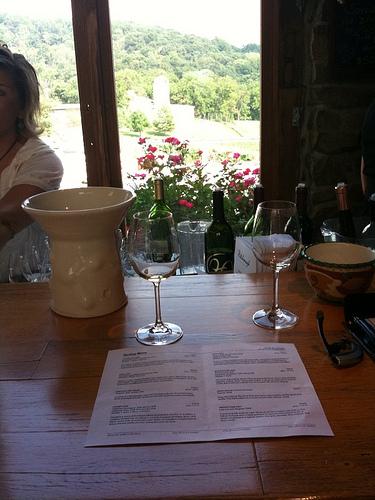How many wine bottles?
Short answer required. 5. Can you see outside form this point?
Be succinct. Yes. What is the white wide-mouth dish used for?
Concise answer only. Fondue. What is over the table?
Give a very brief answer. Menu. 